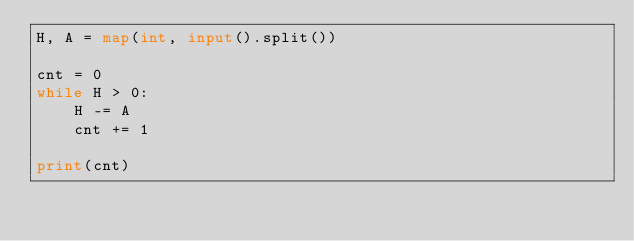<code> <loc_0><loc_0><loc_500><loc_500><_Python_>H, A = map(int, input().split())

cnt = 0
while H > 0:
    H -= A
    cnt += 1

print(cnt)
</code> 